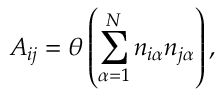Convert formula to latex. <formula><loc_0><loc_0><loc_500><loc_500>A _ { i j } = \theta \left ( \sum _ { \alpha = 1 } ^ { N } n _ { i \alpha } n _ { j \alpha } \right ) ,</formula> 